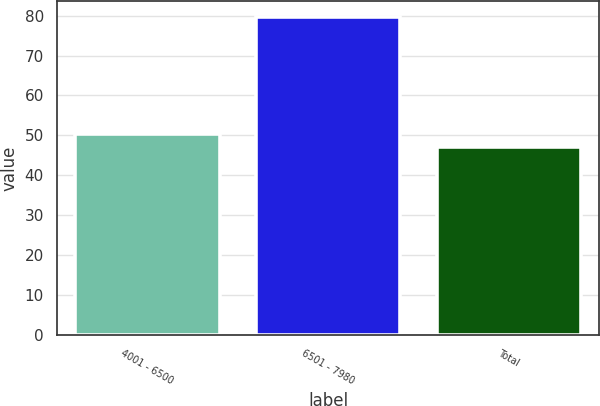<chart> <loc_0><loc_0><loc_500><loc_500><bar_chart><fcel>4001 - 6500<fcel>6501 - 7980<fcel>Total<nl><fcel>50.44<fcel>79.6<fcel>47.2<nl></chart> 